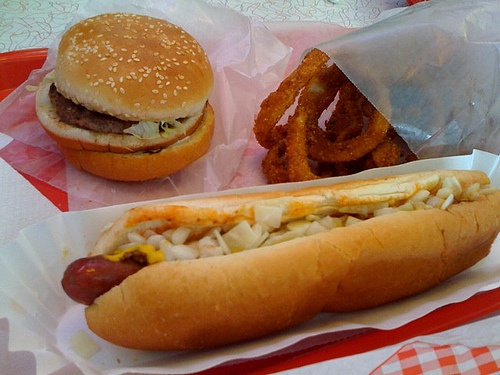Describe the objects in this image and their specific colors. I can see sandwich in darkgray, olive, maroon, and tan tones, hot dog in darkgray, olive, maroon, and tan tones, and sandwich in darkgray, olive, tan, gray, and maroon tones in this image. 